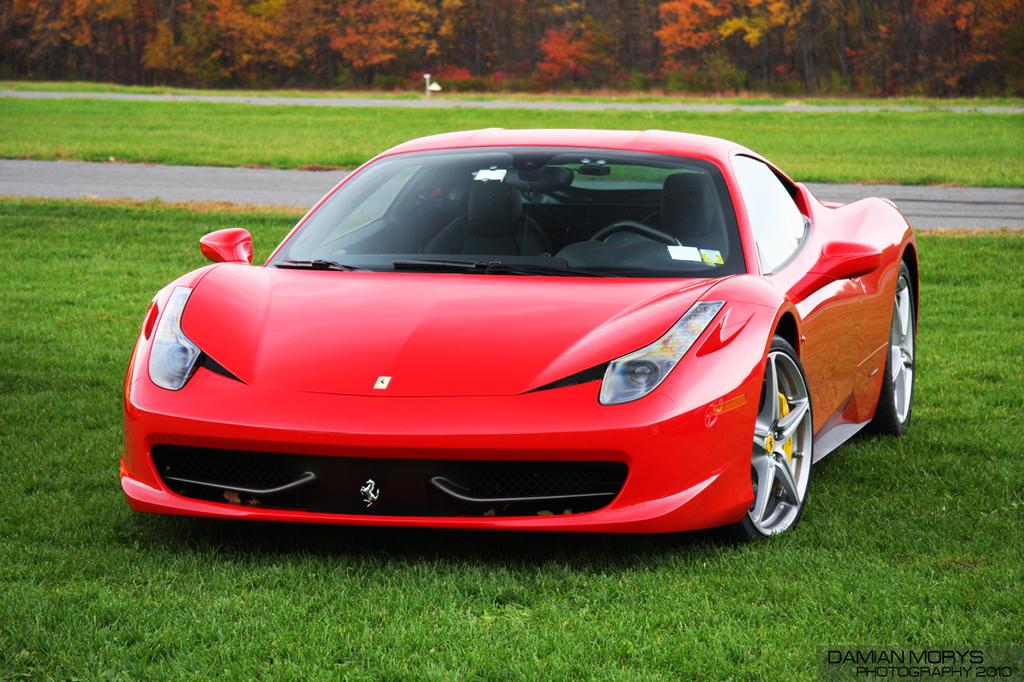What is the main subject in the middle of the image? There is a red car in the middle of the image. What can be seen in the background of the image? There are trees and plants in the background of the image. What type of ground is visible at the bottom of the image? There is grass at the bottom of the image. What is the red car driving on in the image? There is a road in the image. What type of mountain is visible in the background of the image? There is no mountain visible in the background of the image; it features trees and plants. What kind of competition is taking place in the image? There is no competition present in the image; it is a scene with a red car, trees and plants, grass, and a road. 